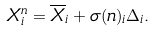Convert formula to latex. <formula><loc_0><loc_0><loc_500><loc_500>X ^ { n } _ { i } = \overline { X } _ { i } + \sigma ( n ) _ { i } \Delta _ { i } .</formula> 